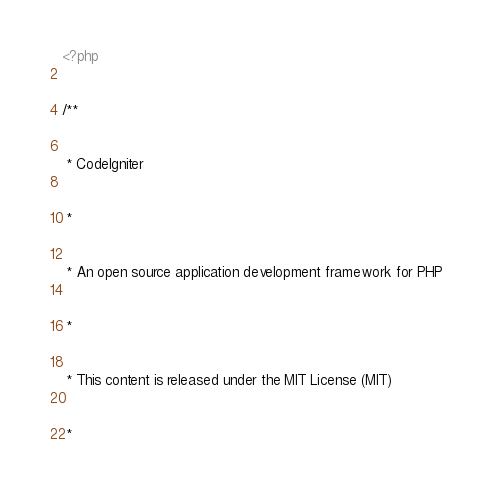<code> <loc_0><loc_0><loc_500><loc_500><_PHP_><?php
/**
 * CodeIgniter
 *
 * An open source application development framework for PHP
 *
 * This content is released under the MIT License (MIT)
 *</code> 